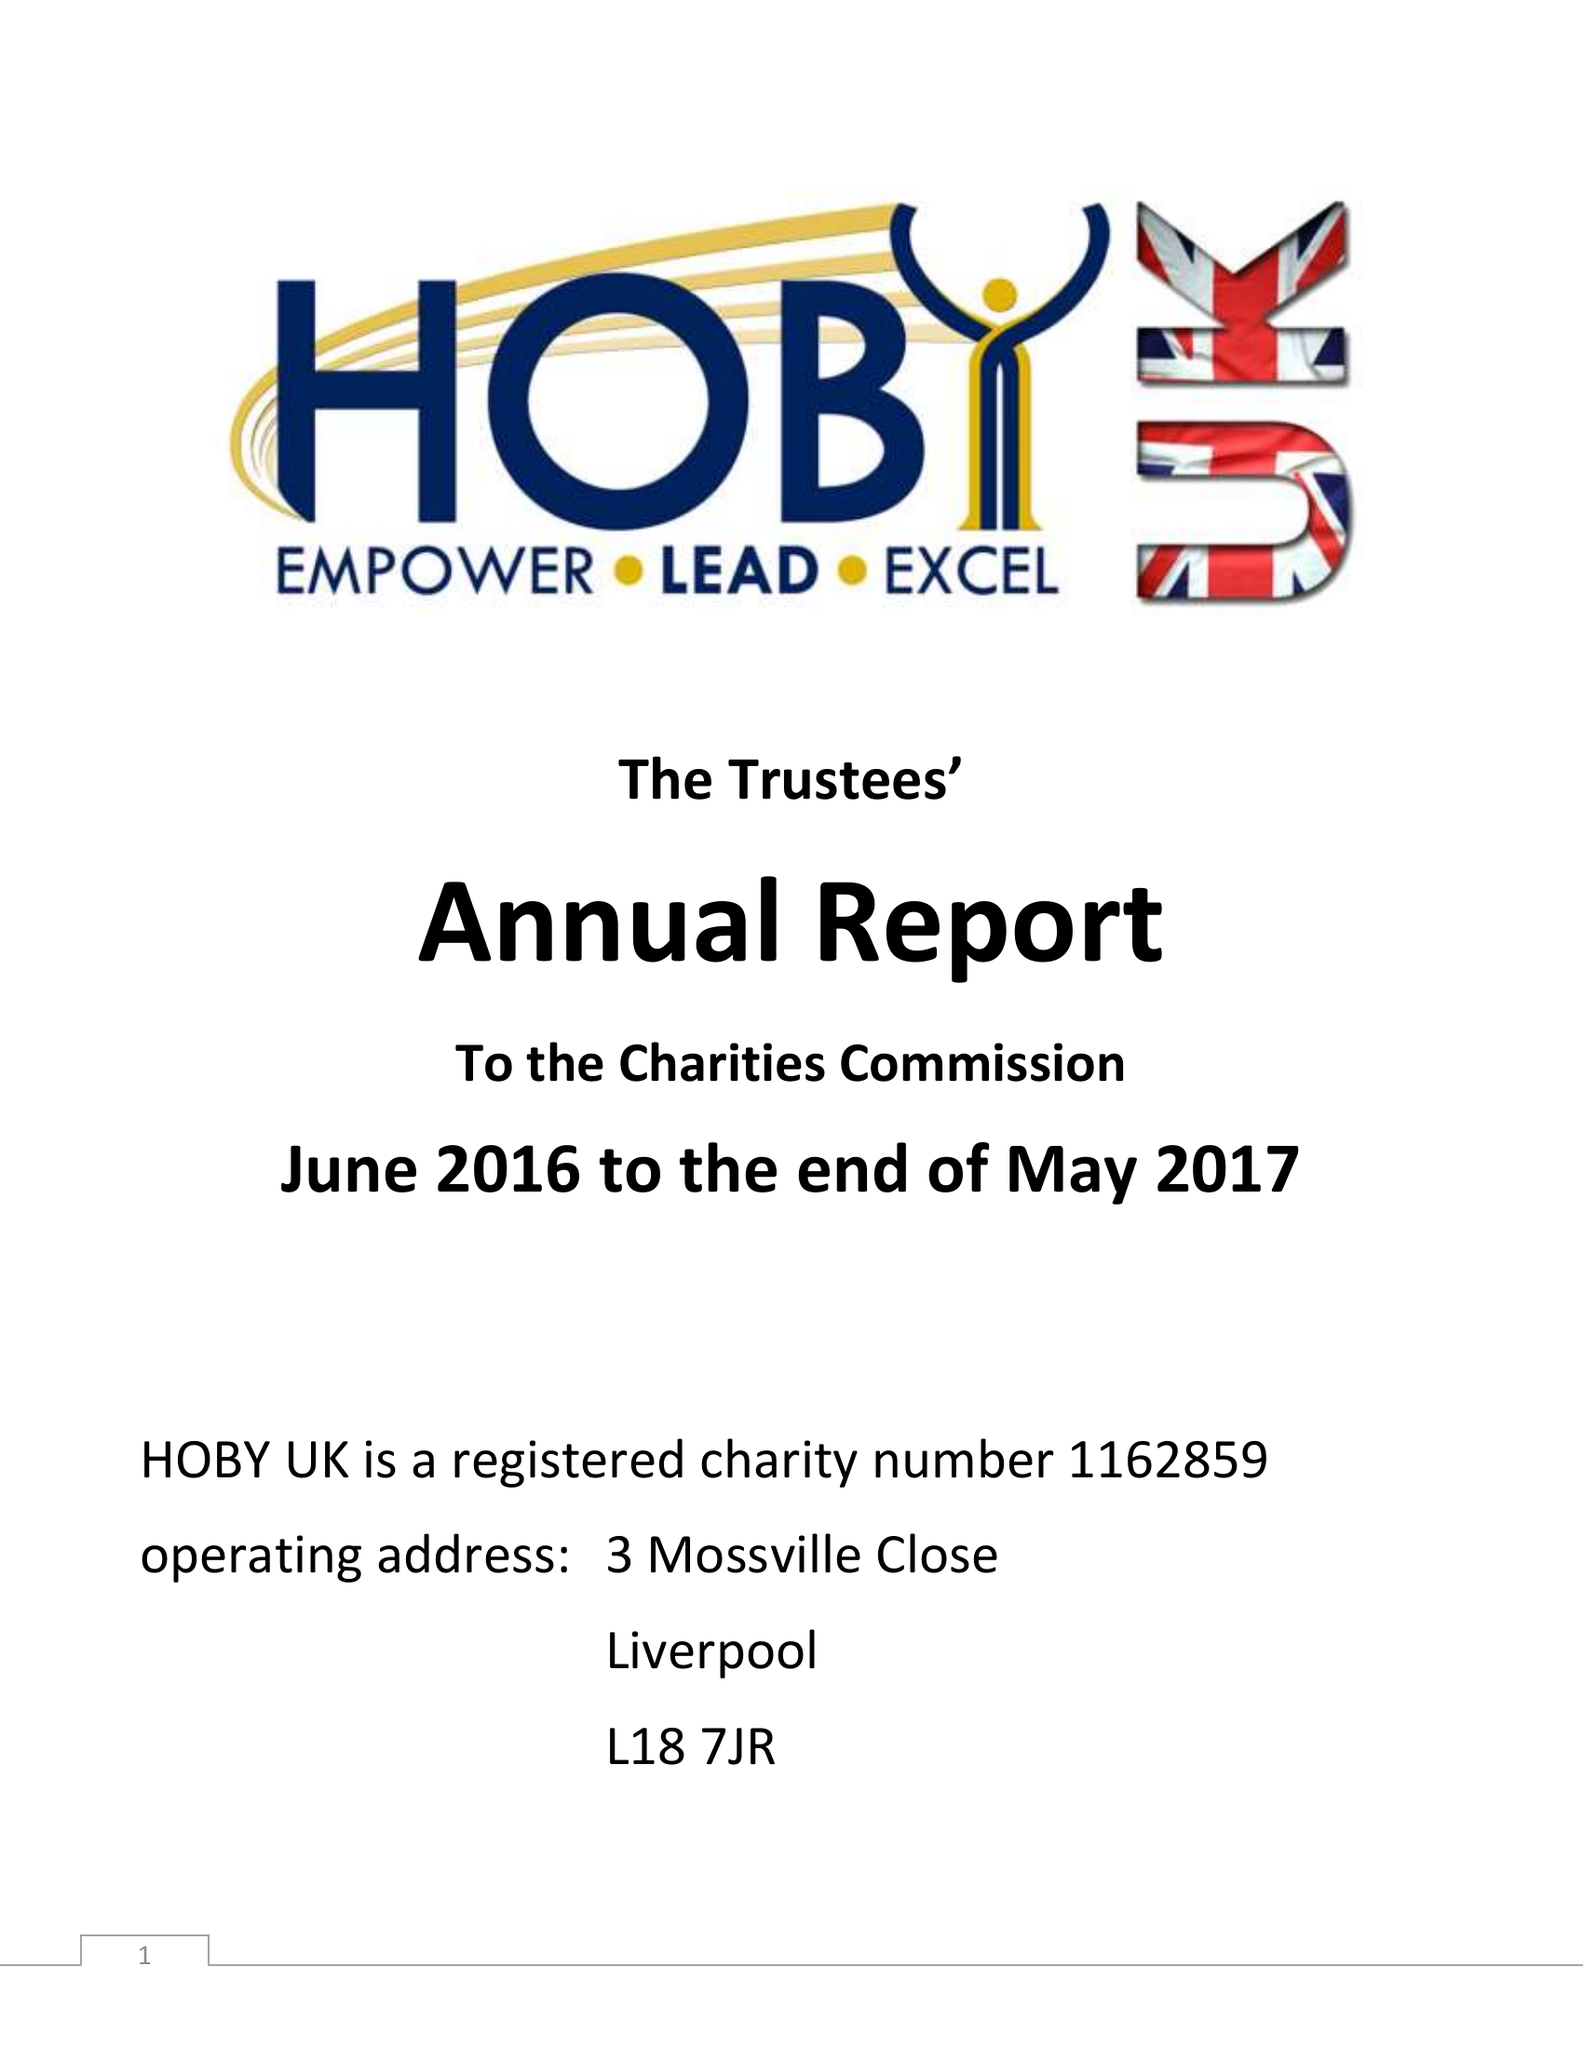What is the value for the address__street_line?
Answer the question using a single word or phrase. 3 MOSSVILLE CLOSE 